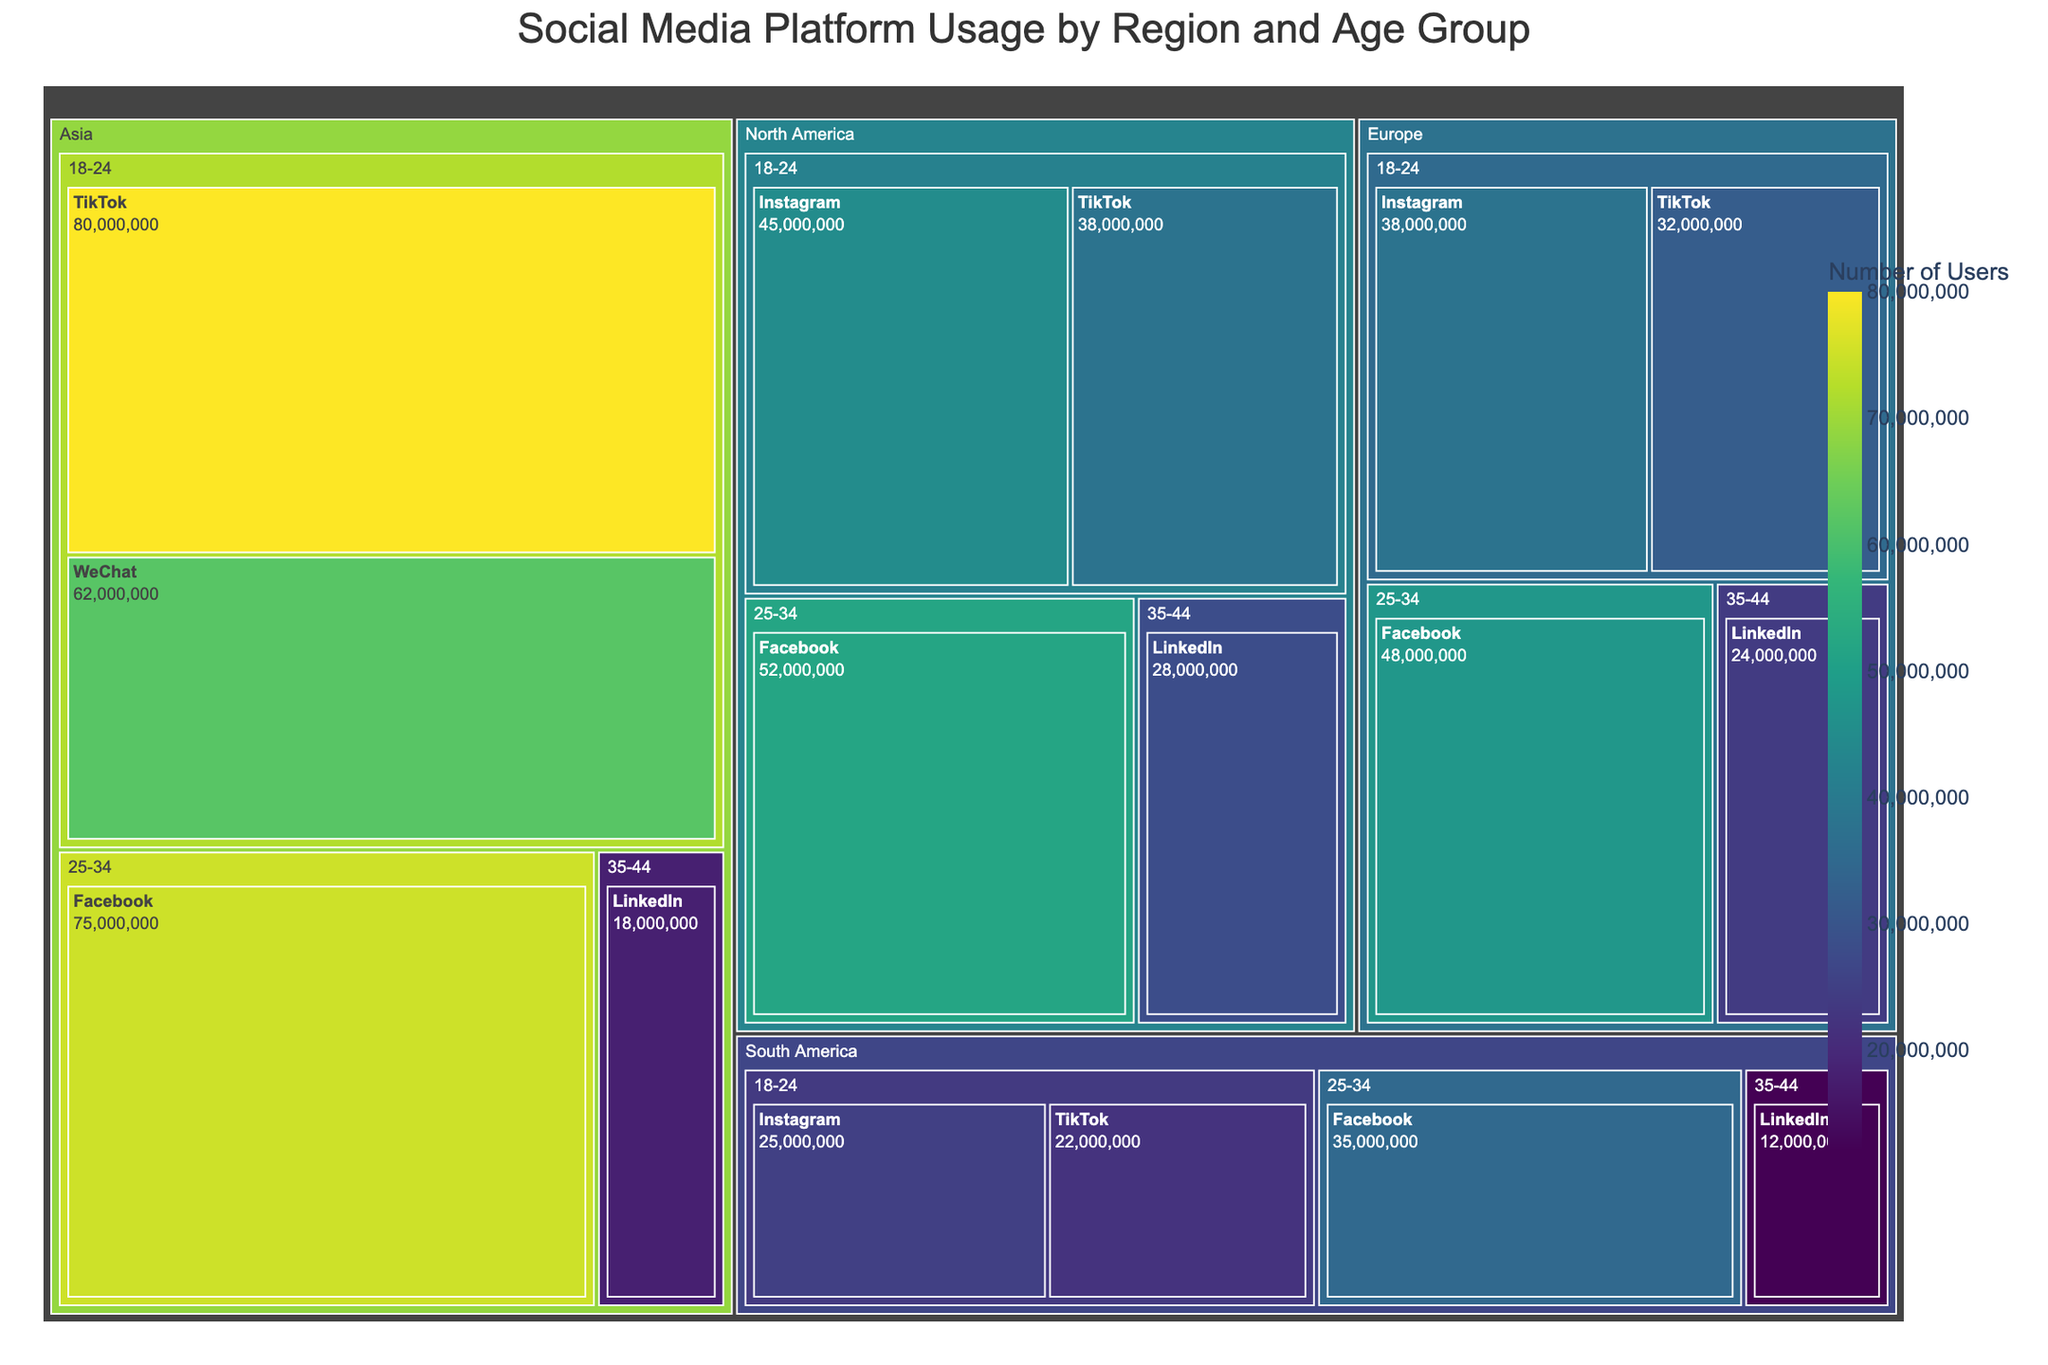Which region has the highest usage of TikTok for the 18-24 age group? From the figure, we can observe that Asia has the largest area representing TikTok usage for the 18-24 age group.
Answer: Asia Which platform has the most users in North America? By visual inspection, the largest single tile for North America corresponds to Facebook.
Answer: Facebook How does the number of Instagram users in Europe for the 18-24 age group compare to North America? In Europe, the number of Instagram users is represented by a fairly large tile. It is slightly smaller than the tile for 18-24 Instagram users in North America, indicating fewer users in Europe.
Answer: Europe has fewer Instagram users in the 18-24 age group than North America Which age group in Asia has the highest usage of TikTok? By examining the treemap, we can see that the tile for TikTok in the 18-24 age group in Asia is the largest for any age group using TikTok.
Answer: 18-24 age group Compare the total number of Facebook users across all regions. Which region ranks first? By summing the values for each region and platform indicated by the size of their tiles, it's evident that Asia has the largest representation for Facebook users.
Answer: Asia How does the number of LinkedIn users in North America for the 35-44 age group compare to South America? In the figure, North America's tile for LinkedIn users in the 35-44 age group is significantly larger than South America's, indicating a higher number of users.
Answer: North America has more LinkedIn users in the 35-44 age group than South America What is the total number of users of Instagram for the 18-24 age group across all regions? Adding up the values from the tiles representing Instagram usage in the 18-24 age group for North America (45,000,000), Europe (38,000,000), and South America (25,000,000), we get 45,000,000 + 38,000,000 + 25,000,000 = 108,000,000 users.
Answer: 108,000,000 Which platform has fewer users in the 25-34 age group in South America compared to North America? Observing the tiles for the 25-34 age group, we see that Facebook is represented in both regions. South America's Facebook tile is smaller than North America's, indicating fewer users in South America.
Answer: Facebook How do the sizes of tiles for LinkedIn usage compare across different regions for the 35-44 age group? The tiles show that North America has the largest, followed by Europe, Asia, and South America in decreasing order for LinkedIn usage in the 35-44 age group.
Answer: North America > Europe > Asia > South America 